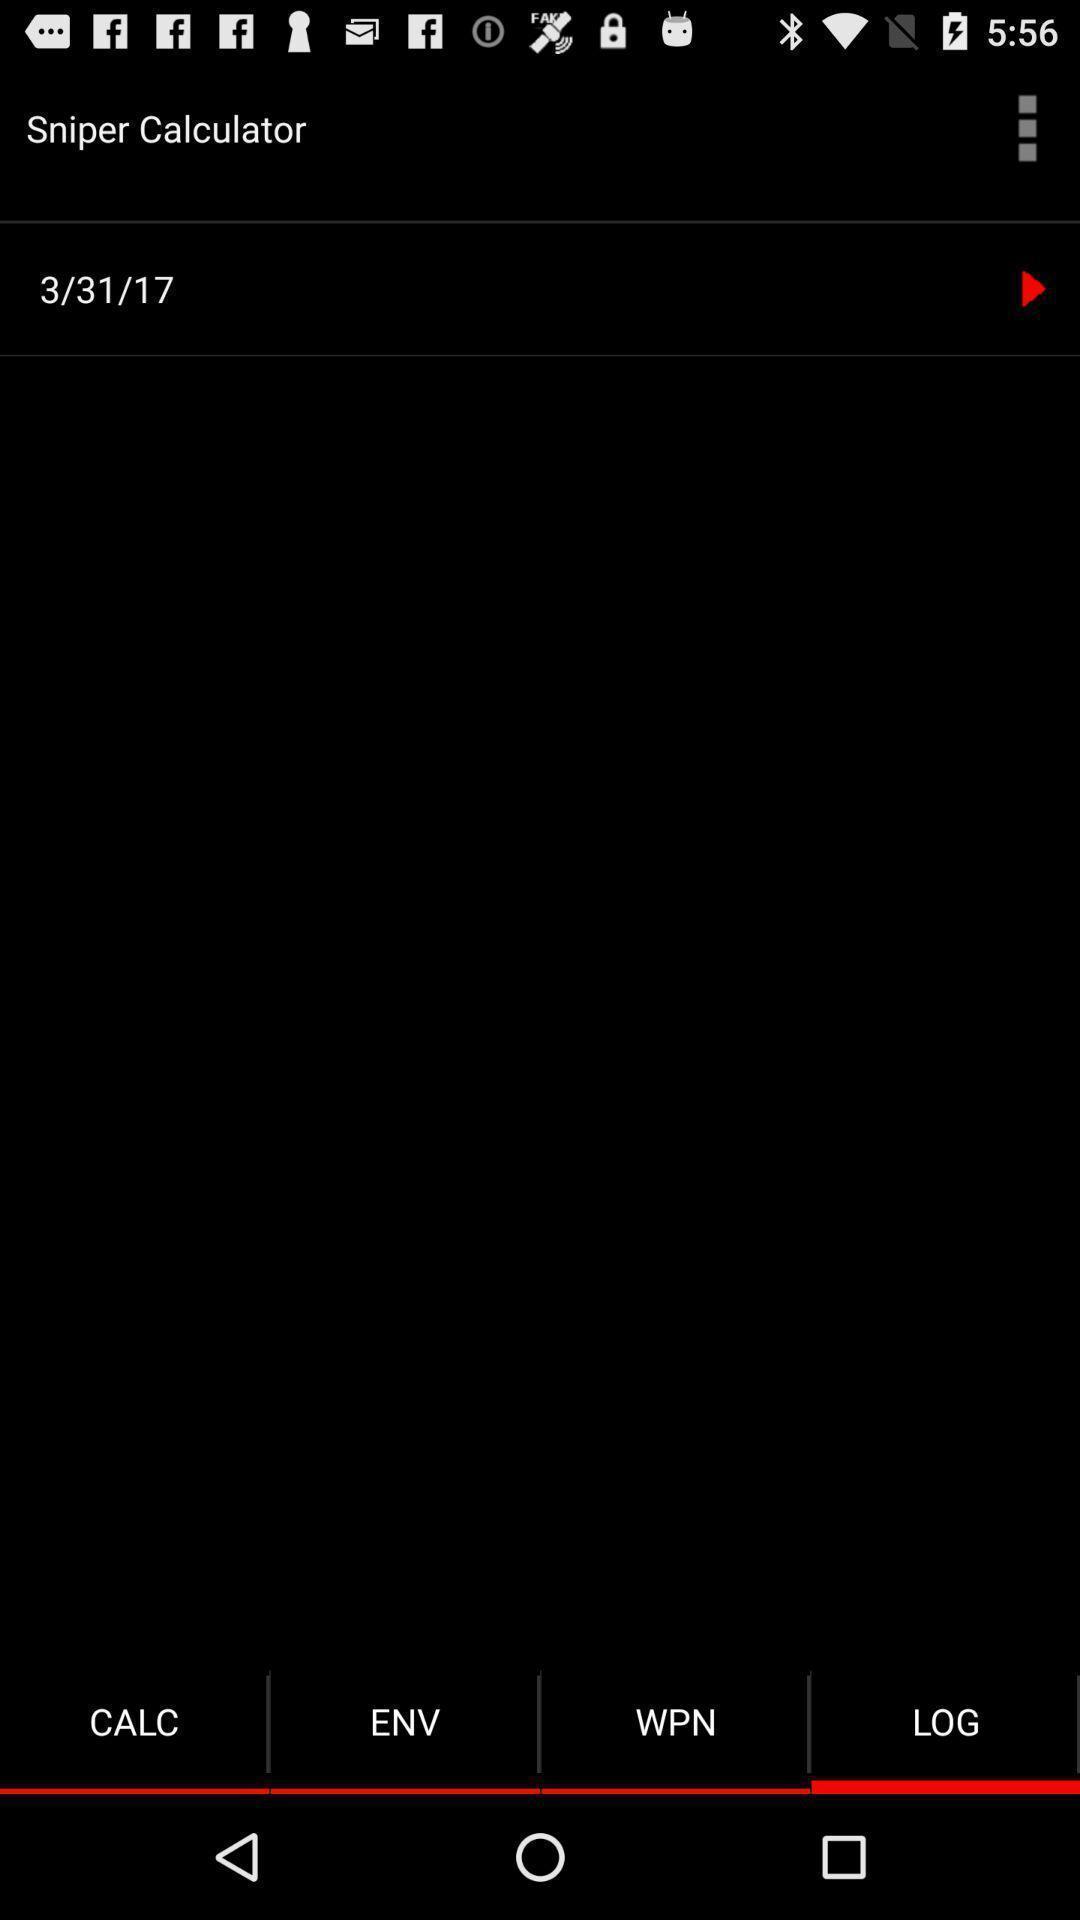What details can you identify in this image? Screen showing log. 